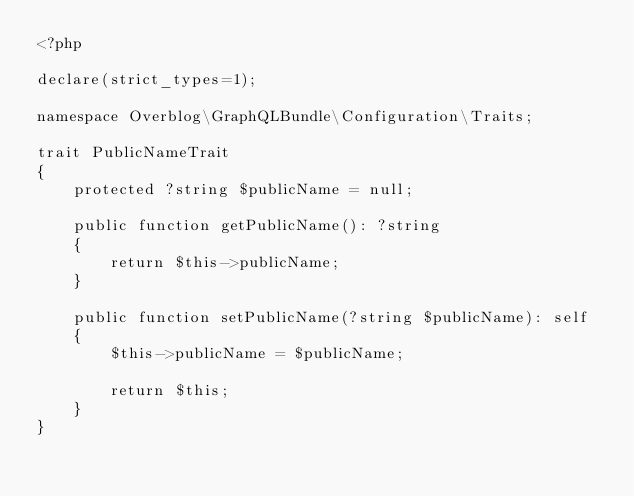<code> <loc_0><loc_0><loc_500><loc_500><_PHP_><?php

declare(strict_types=1);

namespace Overblog\GraphQLBundle\Configuration\Traits;

trait PublicNameTrait
{
    protected ?string $publicName = null;

    public function getPublicName(): ?string
    {
        return $this->publicName;
    }

    public function setPublicName(?string $publicName): self
    {
        $this->publicName = $publicName;

        return $this;
    }
}
</code> 